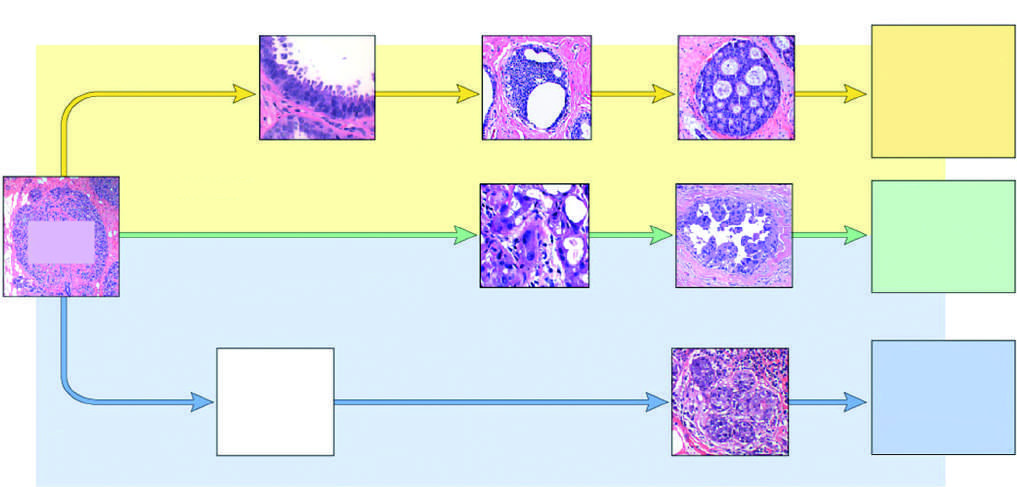re histologic features negative for er and her2 triple negative?
Answer the question using a single word or phrase. No 